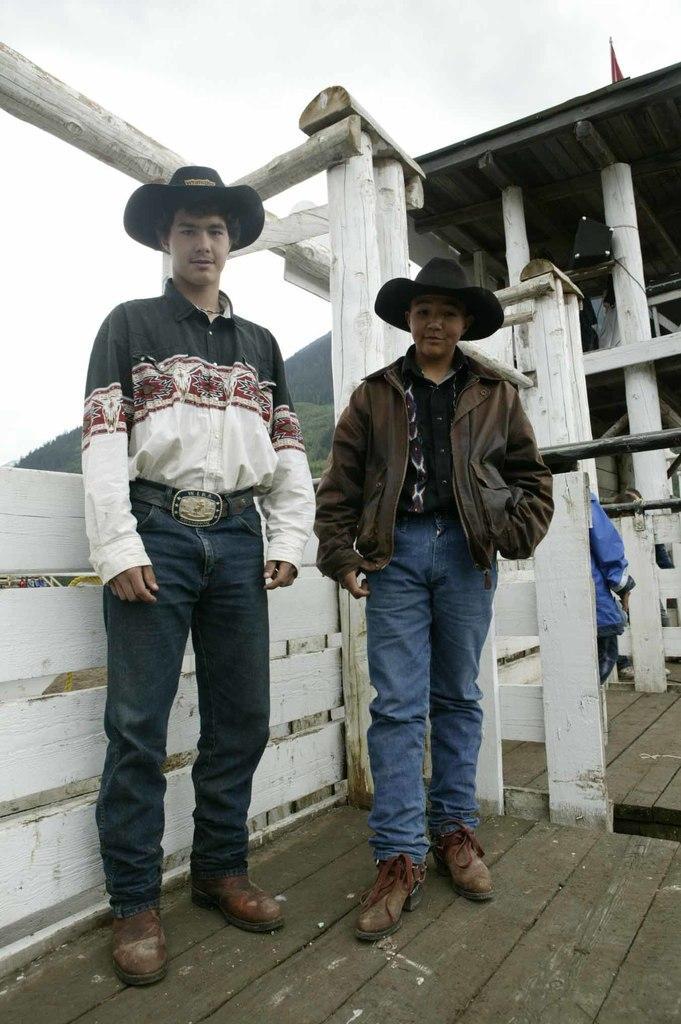Could you give a brief overview of what you see in this image? In this image we can see two men are standing, he is wearing the shirt, at the back, here are the trees, at above here is the sky. 